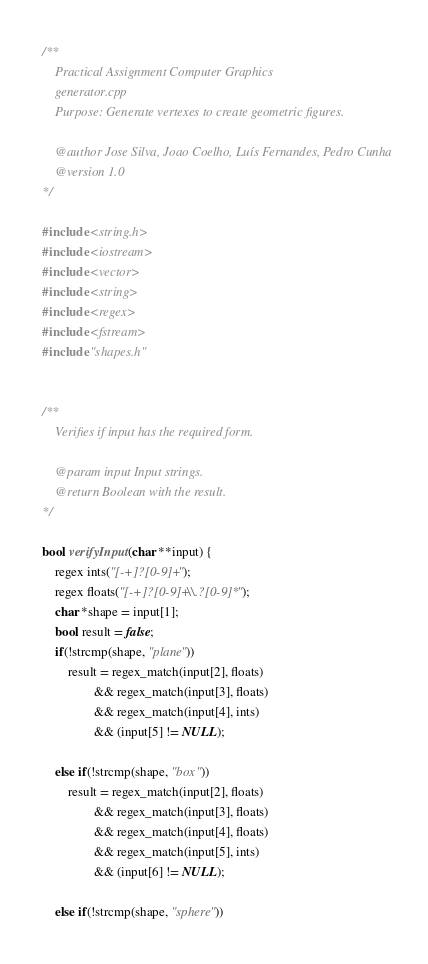<code> <loc_0><loc_0><loc_500><loc_500><_C++_>/**
    Practical Assignment Computer Graphics
    generator.cpp
    Purpose: Generate vertexes to create geometric figures.

    @author Jose Silva, Joao Coelho, Luís Fernandes, Pedro Cunha
    @version 1.0
*/

#include <string.h>
#include <iostream>
#include <vector>
#include <string>
#include <regex>
#include <fstream>
#include "shapes.h"


/**
    Verifies if input has the required form.

    @param input Input strings.
    @return Boolean with the result.
*/

bool verifyInput(char **input) {
    regex ints("[-+]?[0-9]+");
    regex floats("[-+]?[0-9]+\\.?[0-9]*");
    char *shape = input[1];
    bool result = false;
    if(!strcmp(shape, "plane"))
        result = regex_match(input[2], floats)
                && regex_match(input[3], floats)
                && regex_match(input[4], ints)
                && (input[5] != NULL);

    else if(!strcmp(shape, "box"))
        result = regex_match(input[2], floats)
                && regex_match(input[3], floats)
                && regex_match(input[4], floats)
                && regex_match(input[5], ints)
                && (input[6] != NULL);

    else if(!strcmp(shape, "sphere"))</code> 